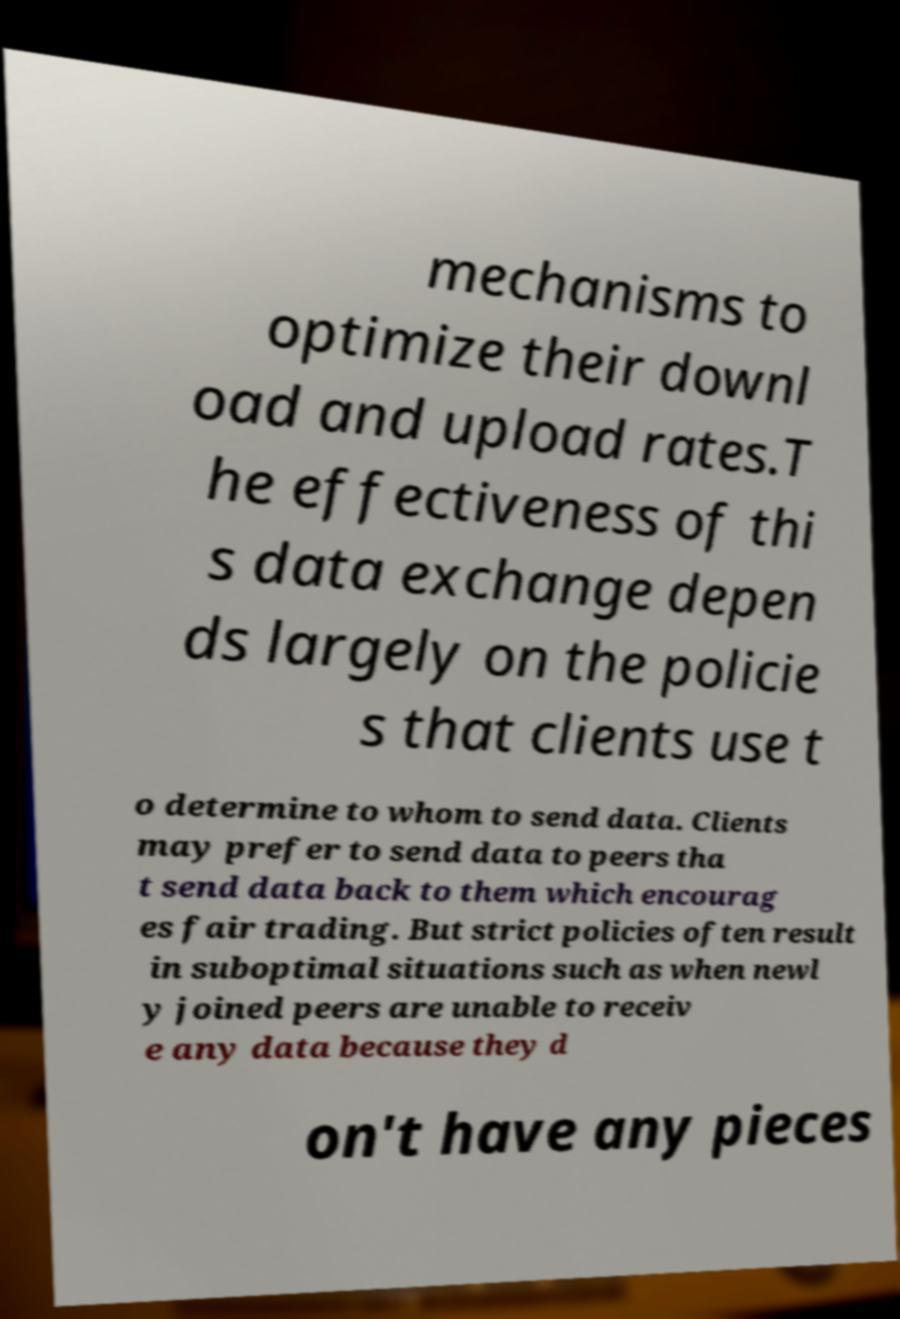There's text embedded in this image that I need extracted. Can you transcribe it verbatim? mechanisms to optimize their downl oad and upload rates.T he effectiveness of thi s data exchange depen ds largely on the policie s that clients use t o determine to whom to send data. Clients may prefer to send data to peers tha t send data back to them which encourag es fair trading. But strict policies often result in suboptimal situations such as when newl y joined peers are unable to receiv e any data because they d on't have any pieces 